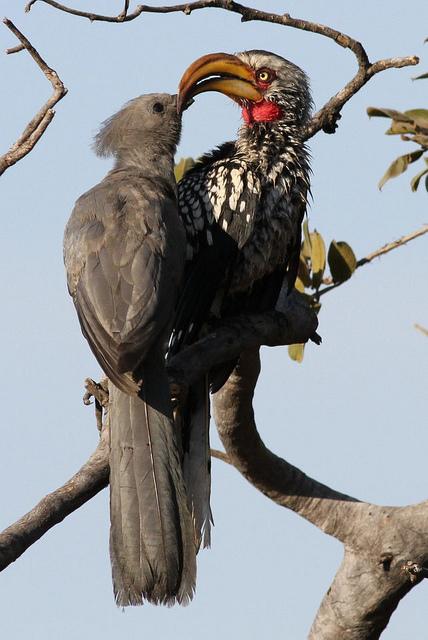What sort of bird is on the left?
Answer briefly. Gray bird. Is the big bird eating the little bird?
Concise answer only. No. Are these birds about the same size?
Write a very short answer. Yes. 